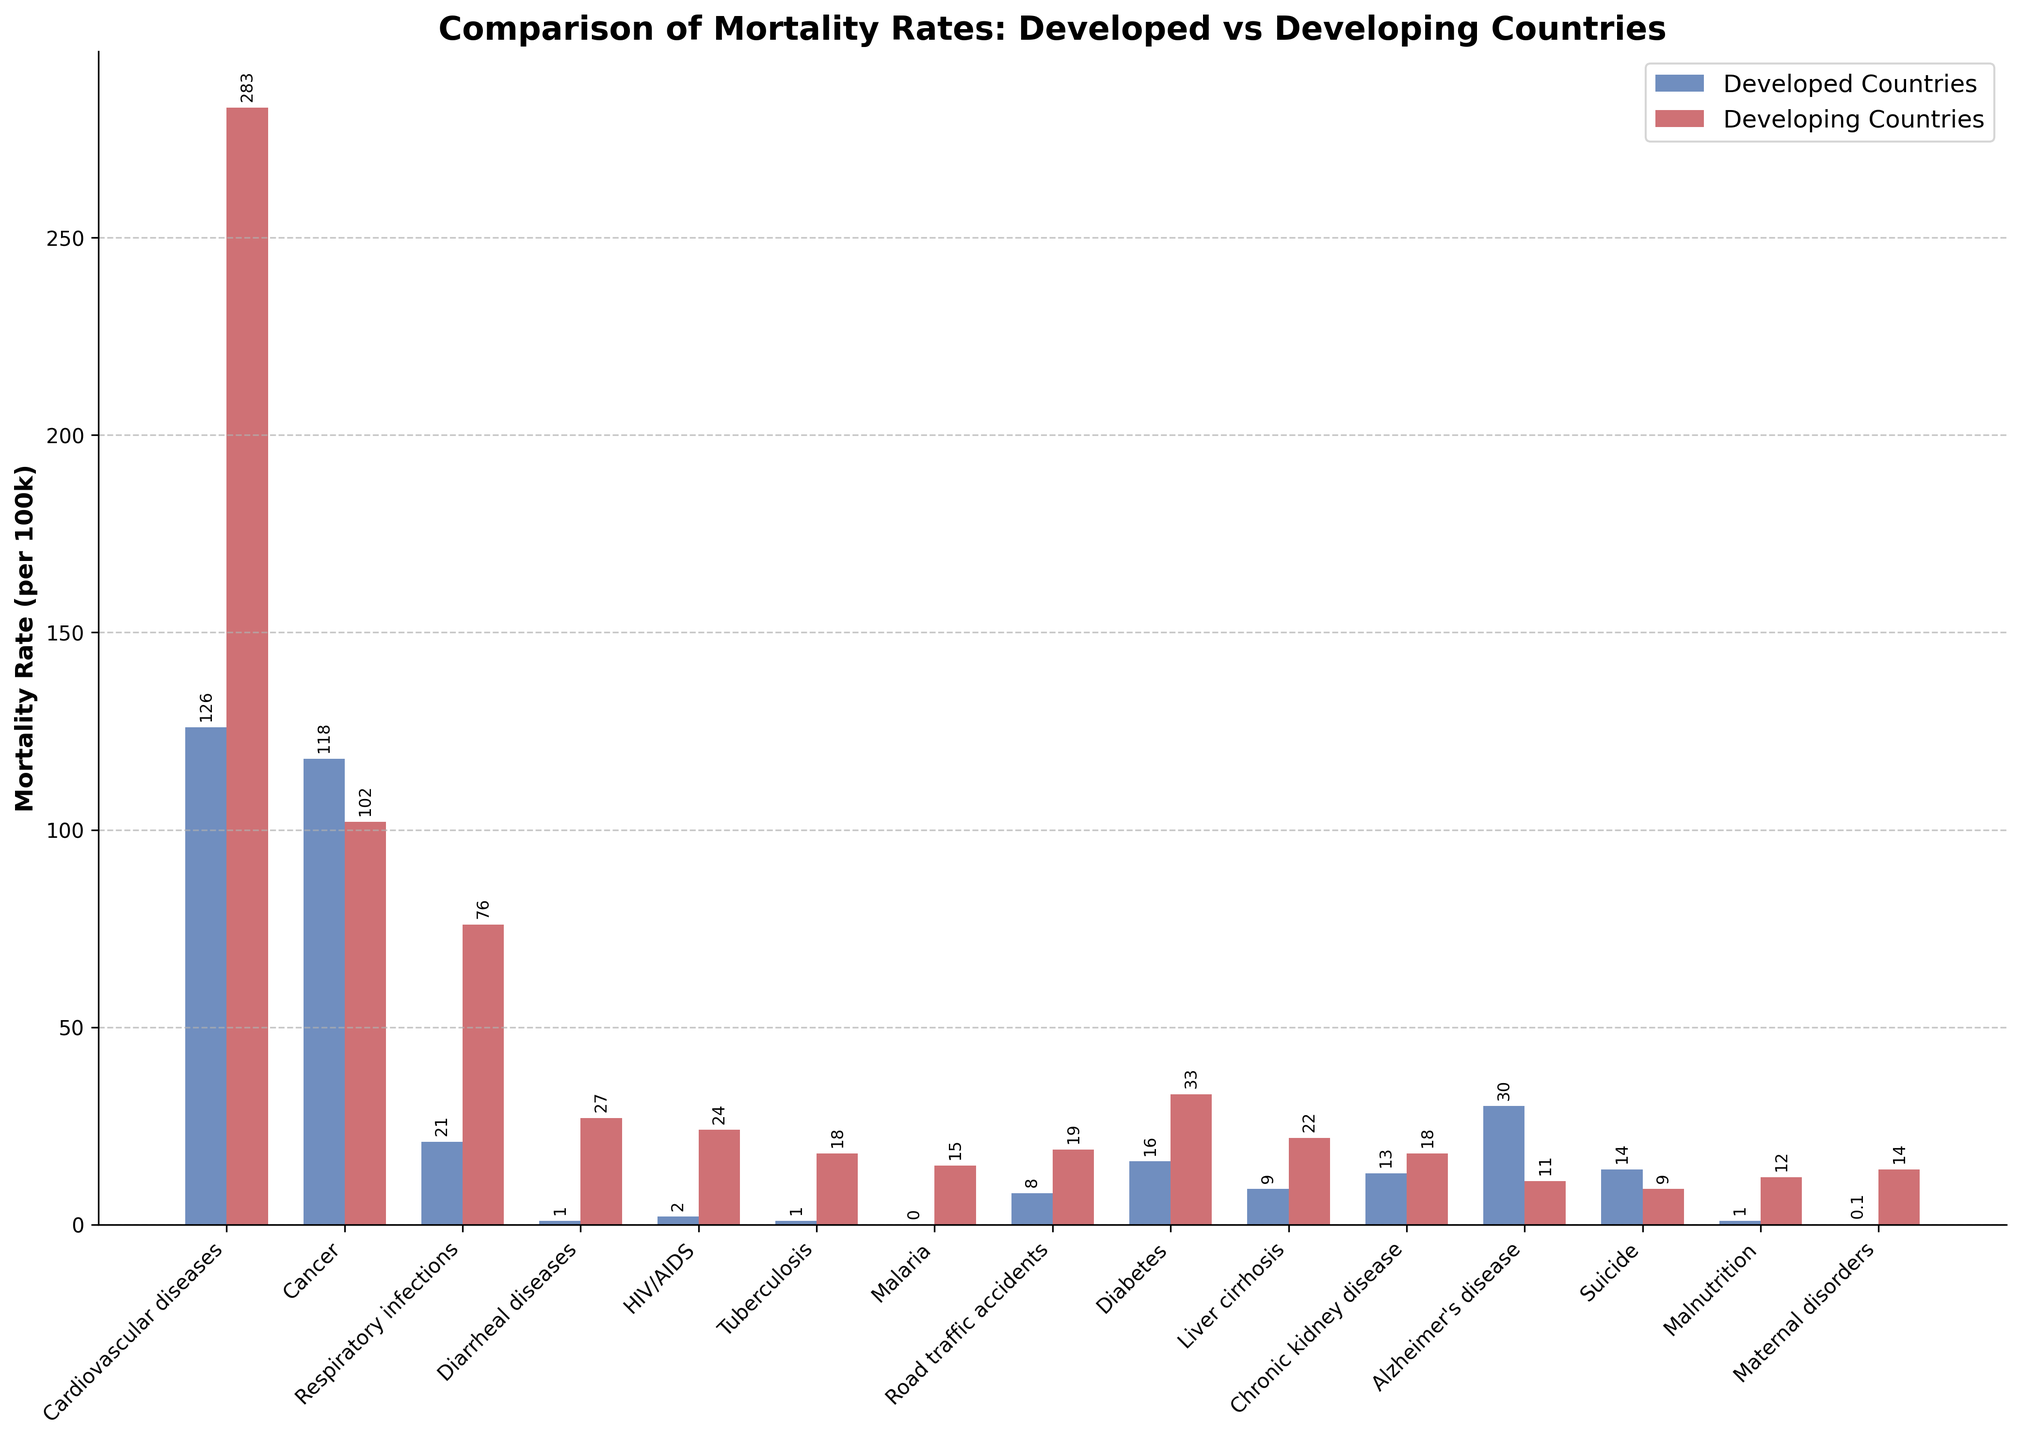Which cause has the highest mortality rate in developed countries? The highest bar representing developed countries is for Cardiovascular diseases.
Answer: Cardiovascular diseases Which cause has the highest mortality rate in developing countries? The highest bar representing developing countries is for Cardiovascular diseases.
Answer: Cardiovascular diseases How many more deaths per 100k are caused by cardiovascular diseases in developing countries compared to developed countries? The bar for Cardiovascular diseases in developing countries shows 283 deaths per 100k, while in developed countries it shows 126 deaths per 100k. Subtracting 126 from 283 gives 157.
Answer: 157 Which causes have a higher mortality rate in developed countries compared to developing countries? By comparing the heights of the bars, Cancer, Alzheimer's disease, and Suicide have higher bars for developed countries compared to developing countries.
Answer: Cancer, Alzheimer's disease, Suicide What is the combined mortality rate for Malaria, HIV/AIDS, and Tuberculosis in developing countries? The mortality rates for Malaria, HIV/AIDS, and Tuberculosis in developing countries are 15, 24, and 18 per 100k, respectively. Adding these together gives 15 + 24 + 18 = 57.
Answer: 57 Compare the mortality rates of Diabetes in developed and developing countries. Which has a higher rate and by how much? The Diabetes mortality rate is 33 per 100k for developing countries and 16 per 100k for developed countries. Subtracting 16 from 33 gives 17.
Answer: Developing countries by 17 per 100k Which causes of mortality have a rate of 1 per 100k in developed countries? The bars representing 1 per 100k in developed countries are for Diarrheal diseases, Tuberculosis, and Malnutrition.
Answer: Diarrheal diseases, Tuberculosis, Malnutrition Which cause of death has the smallest difference in mortality rates between developed and developing countries? Alzheimer's disease has a mortality rate of 30 per 100k in developed countries and 11 per 100k in developing countries. The difference is 30 - 11 = 19, which is the smallest difference among all causes.
Answer: Alzheimer's disease What is the average mortality rate from Cancer in both developed and developing countries? The Cancer mortality rates are 118 per 100k for developed countries and 102 per 100k for developing countries. The average is (118 + 102) / 2 = 110.
Answer: 110 